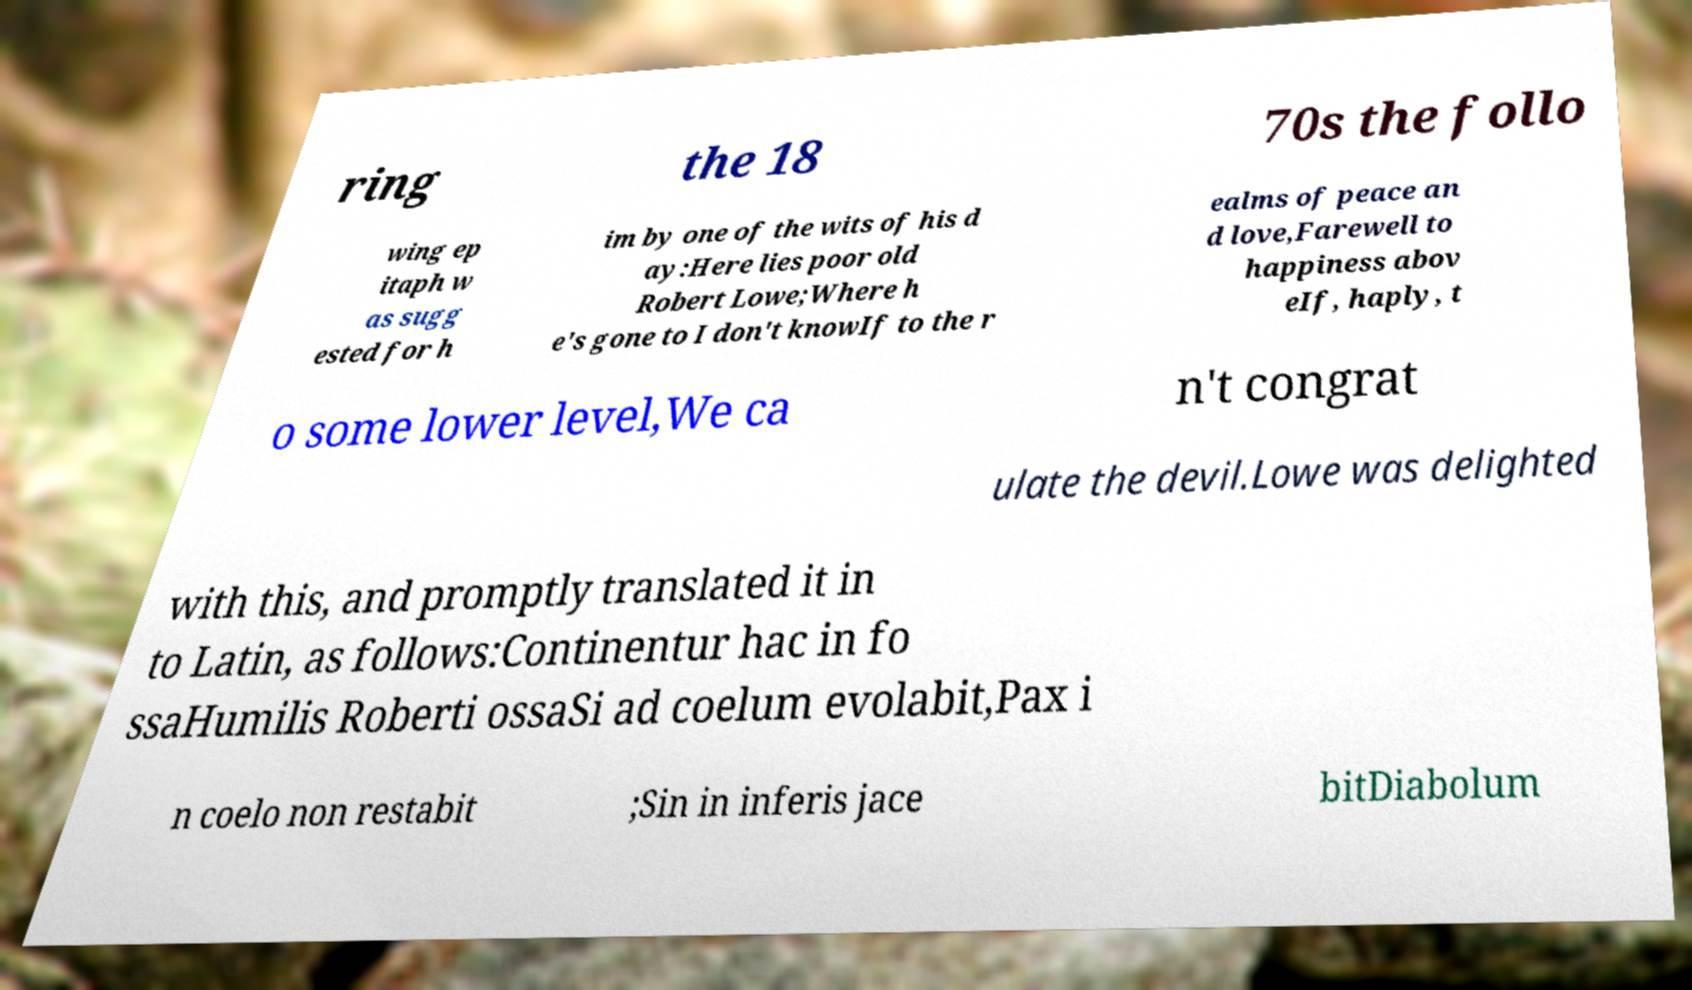There's text embedded in this image that I need extracted. Can you transcribe it verbatim? ring the 18 70s the follo wing ep itaph w as sugg ested for h im by one of the wits of his d ay:Here lies poor old Robert Lowe;Where h e's gone to I don't knowIf to the r ealms of peace an d love,Farewell to happiness abov eIf, haply, t o some lower level,We ca n't congrat ulate the devil.Lowe was delighted with this, and promptly translated it in to Latin, as follows:Continentur hac in fo ssaHumilis Roberti ossaSi ad coelum evolabit,Pax i n coelo non restabit ;Sin in inferis jace bitDiabolum 